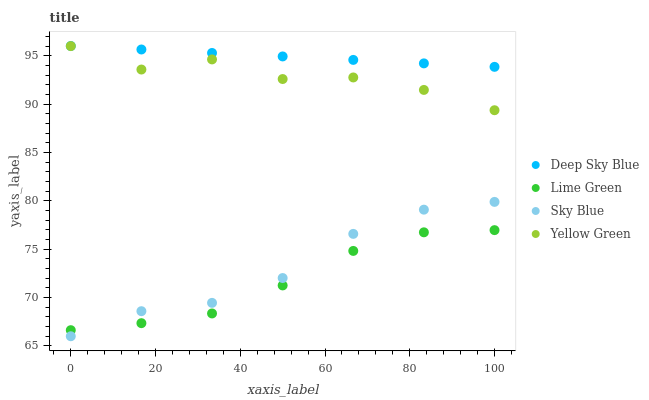Does Lime Green have the minimum area under the curve?
Answer yes or no. Yes. Does Deep Sky Blue have the maximum area under the curve?
Answer yes or no. Yes. Does Yellow Green have the minimum area under the curve?
Answer yes or no. No. Does Yellow Green have the maximum area under the curve?
Answer yes or no. No. Is Deep Sky Blue the smoothest?
Answer yes or no. Yes. Is Yellow Green the roughest?
Answer yes or no. Yes. Is Lime Green the smoothest?
Answer yes or no. No. Is Lime Green the roughest?
Answer yes or no. No. Does Sky Blue have the lowest value?
Answer yes or no. Yes. Does Lime Green have the lowest value?
Answer yes or no. No. Does Deep Sky Blue have the highest value?
Answer yes or no. Yes. Does Yellow Green have the highest value?
Answer yes or no. No. Is Sky Blue less than Deep Sky Blue?
Answer yes or no. Yes. Is Yellow Green greater than Sky Blue?
Answer yes or no. Yes. Does Sky Blue intersect Lime Green?
Answer yes or no. Yes. Is Sky Blue less than Lime Green?
Answer yes or no. No. Is Sky Blue greater than Lime Green?
Answer yes or no. No. Does Sky Blue intersect Deep Sky Blue?
Answer yes or no. No. 